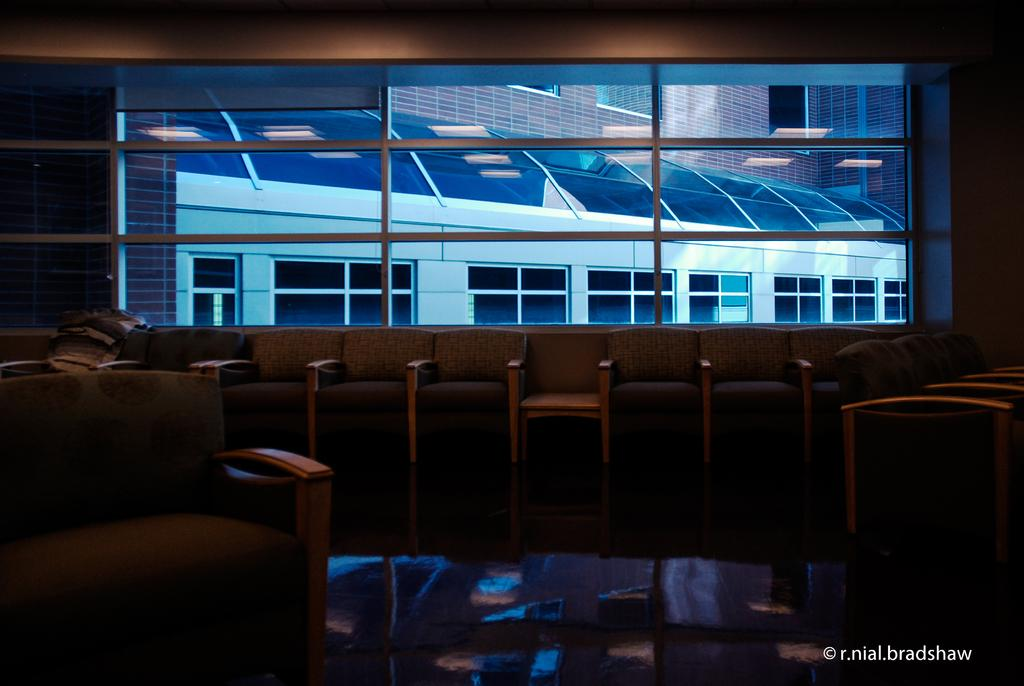How many chairs are visible in the image? There are multiple chairs in the image. What can be seen near the chairs? There is a window in the image. What is visible through the window? A building is visible through the window. What type of toothbrush can be seen on the chair in the image? There is no toothbrush present in the image. How many pears are visible on the chairs in the image? There are no pears visible on the chairs in the image. 